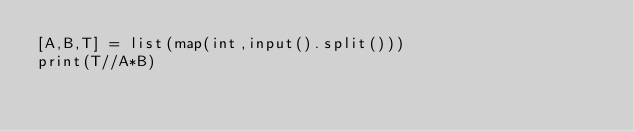Convert code to text. <code><loc_0><loc_0><loc_500><loc_500><_Python_>[A,B,T] = list(map(int,input().split()))
print(T//A*B)
</code> 